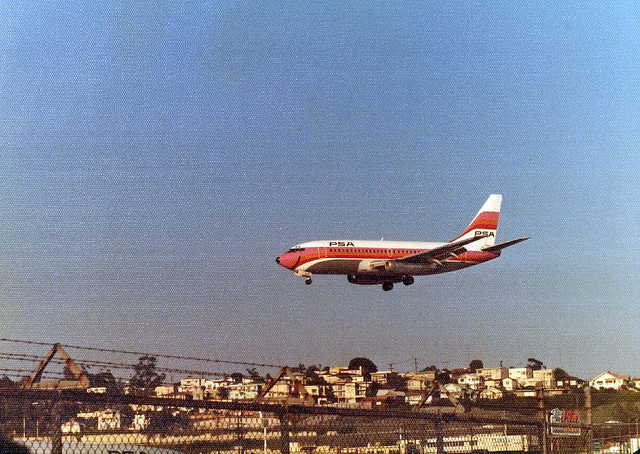What might be the destination or origin of the flight? Due to the low altitude of the airplane above the residential area, it's plausible that the aircraft is either on its final approach to land at a nearby airport or has just taken off. Without additional context, it's not possible to determine the exact destination or origin. 